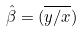Convert formula to latex. <formula><loc_0><loc_0><loc_500><loc_500>\hat { \beta } = ( \overline { y / x } )</formula> 